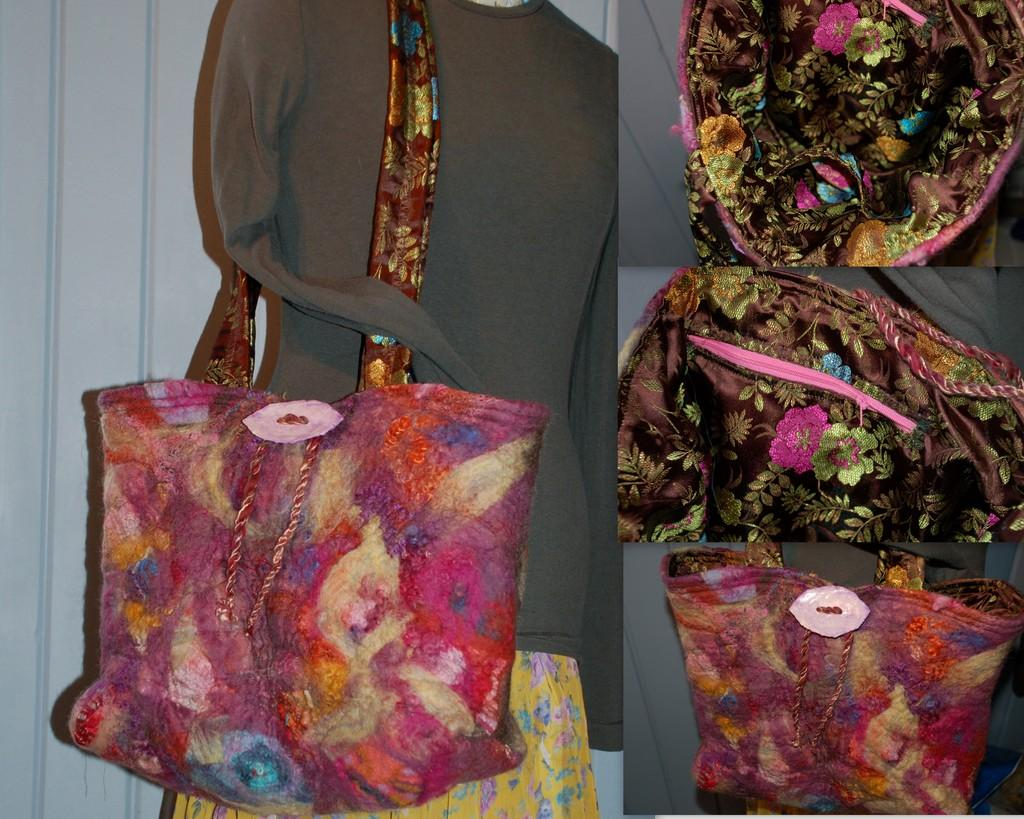What color is the handbag that is attached to the woman's dress? The handbag is pink. How is the pink handbag connected to the woman in the image? The handbag is attached to the woman's dress. What other handbags can be seen in the image? There are other handbags in the image, which are pink and brown in color. Can you describe the harbor in the image? There is no harbor present in the image; it features handbags and a woman. What type of destruction can be seen in the image? There is no destruction present in the image; it is a scene with handbags and a woman. 